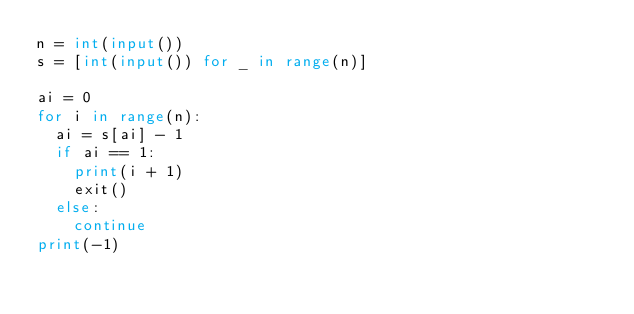Convert code to text. <code><loc_0><loc_0><loc_500><loc_500><_Python_>n = int(input())
s = [int(input()) for _ in range(n)]

ai = 0
for i in range(n):
  ai = s[ai] - 1
  if ai == 1:
    print(i + 1)
    exit()
  else:
    continue
print(-1)</code> 